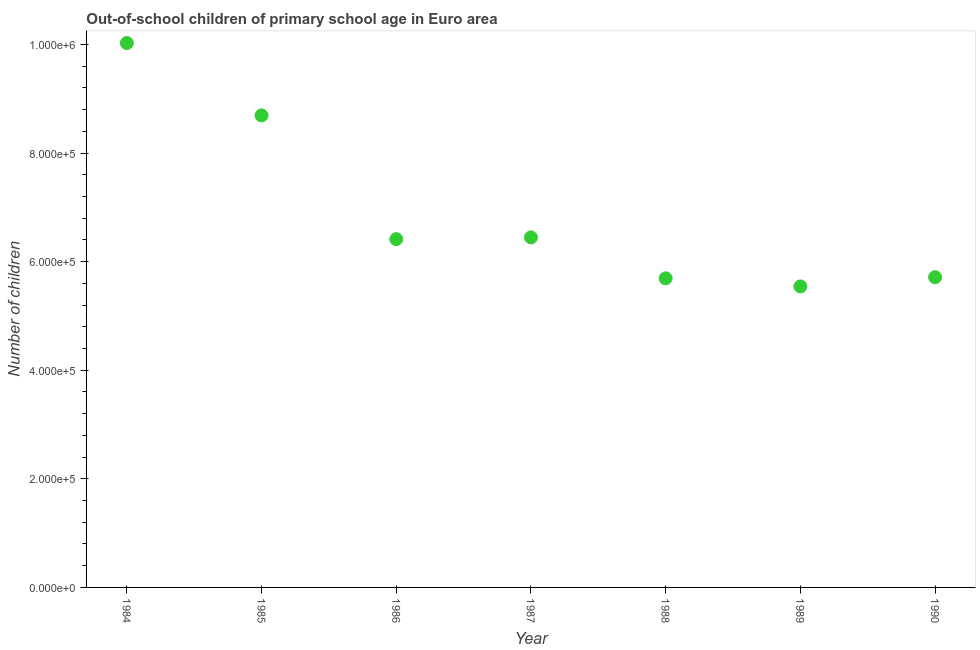What is the number of out-of-school children in 1989?
Provide a succinct answer. 5.54e+05. Across all years, what is the maximum number of out-of-school children?
Provide a succinct answer. 1.00e+06. Across all years, what is the minimum number of out-of-school children?
Offer a terse response. 5.54e+05. In which year was the number of out-of-school children minimum?
Your response must be concise. 1989. What is the sum of the number of out-of-school children?
Offer a terse response. 4.85e+06. What is the difference between the number of out-of-school children in 1985 and 1989?
Your answer should be compact. 3.15e+05. What is the average number of out-of-school children per year?
Provide a short and direct response. 6.93e+05. What is the median number of out-of-school children?
Make the answer very short. 6.42e+05. In how many years, is the number of out-of-school children greater than 200000 ?
Your answer should be very brief. 7. What is the ratio of the number of out-of-school children in 1986 to that in 1990?
Your answer should be compact. 1.12. Is the number of out-of-school children in 1986 less than that in 1988?
Your answer should be compact. No. Is the difference between the number of out-of-school children in 1986 and 1988 greater than the difference between any two years?
Give a very brief answer. No. What is the difference between the highest and the second highest number of out-of-school children?
Give a very brief answer. 1.33e+05. Is the sum of the number of out-of-school children in 1984 and 1986 greater than the maximum number of out-of-school children across all years?
Your answer should be very brief. Yes. What is the difference between the highest and the lowest number of out-of-school children?
Offer a very short reply. 4.48e+05. How many dotlines are there?
Offer a very short reply. 1. What is the difference between two consecutive major ticks on the Y-axis?
Your response must be concise. 2.00e+05. Does the graph contain any zero values?
Keep it short and to the point. No. Does the graph contain grids?
Your answer should be very brief. No. What is the title of the graph?
Your response must be concise. Out-of-school children of primary school age in Euro area. What is the label or title of the X-axis?
Your response must be concise. Year. What is the label or title of the Y-axis?
Make the answer very short. Number of children. What is the Number of children in 1984?
Offer a terse response. 1.00e+06. What is the Number of children in 1985?
Give a very brief answer. 8.69e+05. What is the Number of children in 1986?
Your answer should be compact. 6.42e+05. What is the Number of children in 1987?
Your answer should be compact. 6.45e+05. What is the Number of children in 1988?
Make the answer very short. 5.69e+05. What is the Number of children in 1989?
Make the answer very short. 5.54e+05. What is the Number of children in 1990?
Offer a very short reply. 5.71e+05. What is the difference between the Number of children in 1984 and 1985?
Give a very brief answer. 1.33e+05. What is the difference between the Number of children in 1984 and 1986?
Ensure brevity in your answer.  3.61e+05. What is the difference between the Number of children in 1984 and 1987?
Make the answer very short. 3.58e+05. What is the difference between the Number of children in 1984 and 1988?
Make the answer very short. 4.33e+05. What is the difference between the Number of children in 1984 and 1989?
Make the answer very short. 4.48e+05. What is the difference between the Number of children in 1984 and 1990?
Ensure brevity in your answer.  4.31e+05. What is the difference between the Number of children in 1985 and 1986?
Provide a succinct answer. 2.28e+05. What is the difference between the Number of children in 1985 and 1987?
Make the answer very short. 2.25e+05. What is the difference between the Number of children in 1985 and 1988?
Give a very brief answer. 3.00e+05. What is the difference between the Number of children in 1985 and 1989?
Offer a terse response. 3.15e+05. What is the difference between the Number of children in 1985 and 1990?
Offer a terse response. 2.98e+05. What is the difference between the Number of children in 1986 and 1987?
Offer a terse response. -3207. What is the difference between the Number of children in 1986 and 1988?
Your response must be concise. 7.22e+04. What is the difference between the Number of children in 1986 and 1989?
Offer a terse response. 8.70e+04. What is the difference between the Number of children in 1986 and 1990?
Your response must be concise. 7.01e+04. What is the difference between the Number of children in 1987 and 1988?
Make the answer very short. 7.54e+04. What is the difference between the Number of children in 1987 and 1989?
Ensure brevity in your answer.  9.02e+04. What is the difference between the Number of children in 1987 and 1990?
Ensure brevity in your answer.  7.33e+04. What is the difference between the Number of children in 1988 and 1989?
Offer a terse response. 1.49e+04. What is the difference between the Number of children in 1988 and 1990?
Your response must be concise. -2068. What is the difference between the Number of children in 1989 and 1990?
Provide a succinct answer. -1.70e+04. What is the ratio of the Number of children in 1984 to that in 1985?
Your answer should be compact. 1.15. What is the ratio of the Number of children in 1984 to that in 1986?
Your answer should be compact. 1.56. What is the ratio of the Number of children in 1984 to that in 1987?
Provide a short and direct response. 1.55. What is the ratio of the Number of children in 1984 to that in 1988?
Make the answer very short. 1.76. What is the ratio of the Number of children in 1984 to that in 1989?
Provide a succinct answer. 1.81. What is the ratio of the Number of children in 1984 to that in 1990?
Your answer should be very brief. 1.75. What is the ratio of the Number of children in 1985 to that in 1986?
Your answer should be compact. 1.35. What is the ratio of the Number of children in 1985 to that in 1987?
Provide a short and direct response. 1.35. What is the ratio of the Number of children in 1985 to that in 1988?
Your answer should be very brief. 1.53. What is the ratio of the Number of children in 1985 to that in 1989?
Your answer should be very brief. 1.57. What is the ratio of the Number of children in 1985 to that in 1990?
Provide a succinct answer. 1.52. What is the ratio of the Number of children in 1986 to that in 1987?
Your answer should be compact. 0.99. What is the ratio of the Number of children in 1986 to that in 1988?
Make the answer very short. 1.13. What is the ratio of the Number of children in 1986 to that in 1989?
Give a very brief answer. 1.16. What is the ratio of the Number of children in 1986 to that in 1990?
Your response must be concise. 1.12. What is the ratio of the Number of children in 1987 to that in 1988?
Give a very brief answer. 1.13. What is the ratio of the Number of children in 1987 to that in 1989?
Your response must be concise. 1.16. What is the ratio of the Number of children in 1987 to that in 1990?
Provide a succinct answer. 1.13. What is the ratio of the Number of children in 1988 to that in 1990?
Provide a succinct answer. 1. What is the ratio of the Number of children in 1989 to that in 1990?
Give a very brief answer. 0.97. 